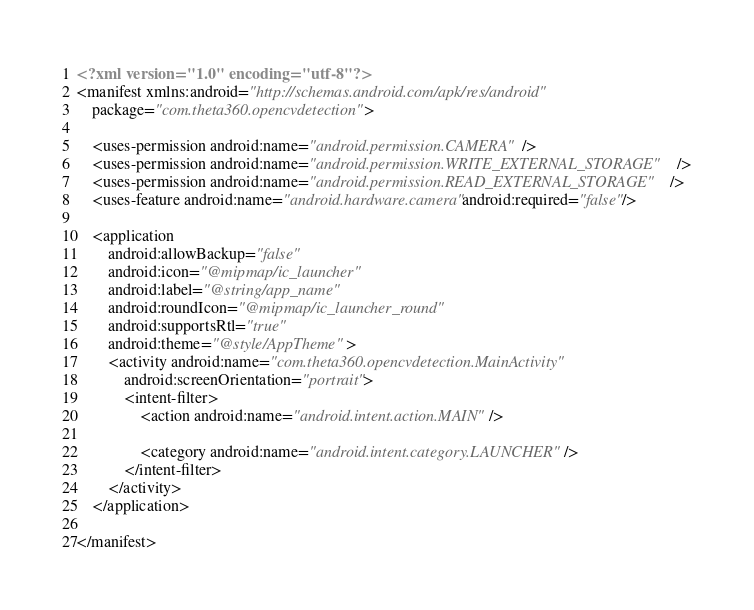Convert code to text. <code><loc_0><loc_0><loc_500><loc_500><_XML_><?xml version="1.0" encoding="utf-8"?>
<manifest xmlns:android="http://schemas.android.com/apk/res/android"
    package="com.theta360.opencvdetection">

    <uses-permission android:name="android.permission.CAMERA" />
    <uses-permission android:name="android.permission.WRITE_EXTERNAL_STORAGE" />
    <uses-permission android:name="android.permission.READ_EXTERNAL_STORAGE" />
    <uses-feature android:name="android.hardware.camera" android:required="false"/>

    <application
        android:allowBackup="false"
        android:icon="@mipmap/ic_launcher"
        android:label="@string/app_name"
        android:roundIcon="@mipmap/ic_launcher_round"
        android:supportsRtl="true"
        android:theme="@style/AppTheme">
        <activity android:name="com.theta360.opencvdetection.MainActivity"
            android:screenOrientation="portrait">
            <intent-filter>
                <action android:name="android.intent.action.MAIN" />

                <category android:name="android.intent.category.LAUNCHER" />
            </intent-filter>
        </activity>
    </application>

</manifest></code> 